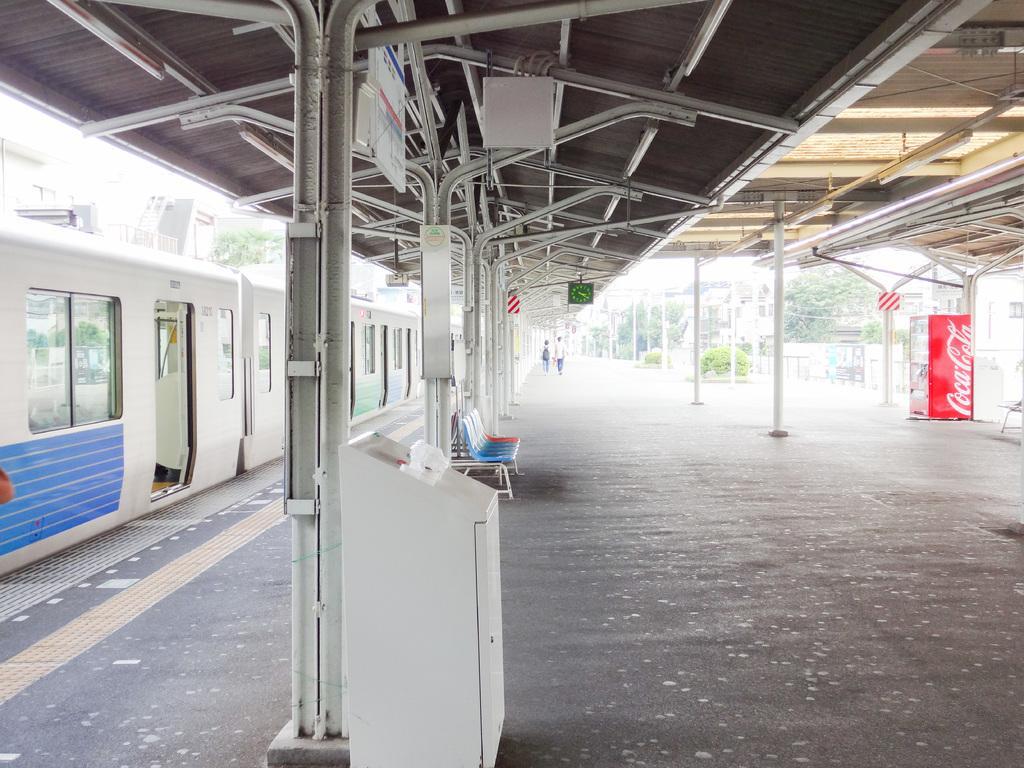Describe this image in one or two sentences. In this image we can see chairs, poles, platform, clock, roof, boards, white color machine and trees. On the left side of the image, we can see the train. On the right side of the image, we can see a refrigerator. 